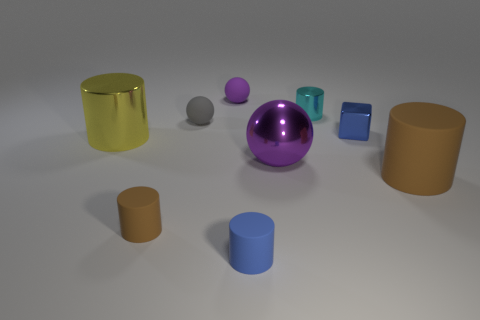The cylinder that is the same material as the cyan thing is what size?
Provide a succinct answer. Large. How many blocks are either tiny blue metal objects or brown things?
Offer a terse response. 1. Are there more gray rubber objects than brown matte spheres?
Make the answer very short. Yes. What number of purple things have the same size as the yellow metal cylinder?
Keep it short and to the point. 1. What is the shape of the thing that is the same color as the big sphere?
Your answer should be compact. Sphere. What number of things are either brown rubber cylinders that are on the right side of the small metal block or small cyan spheres?
Your answer should be compact. 1. Are there fewer rubber objects than tiny objects?
Ensure brevity in your answer.  Yes. What is the shape of the small brown thing that is the same material as the tiny gray sphere?
Ensure brevity in your answer.  Cylinder. There is a small brown matte cylinder; are there any brown objects in front of it?
Offer a terse response. No. Is the number of large shiny balls on the left side of the big purple sphere less than the number of big gray cylinders?
Provide a short and direct response. No. 